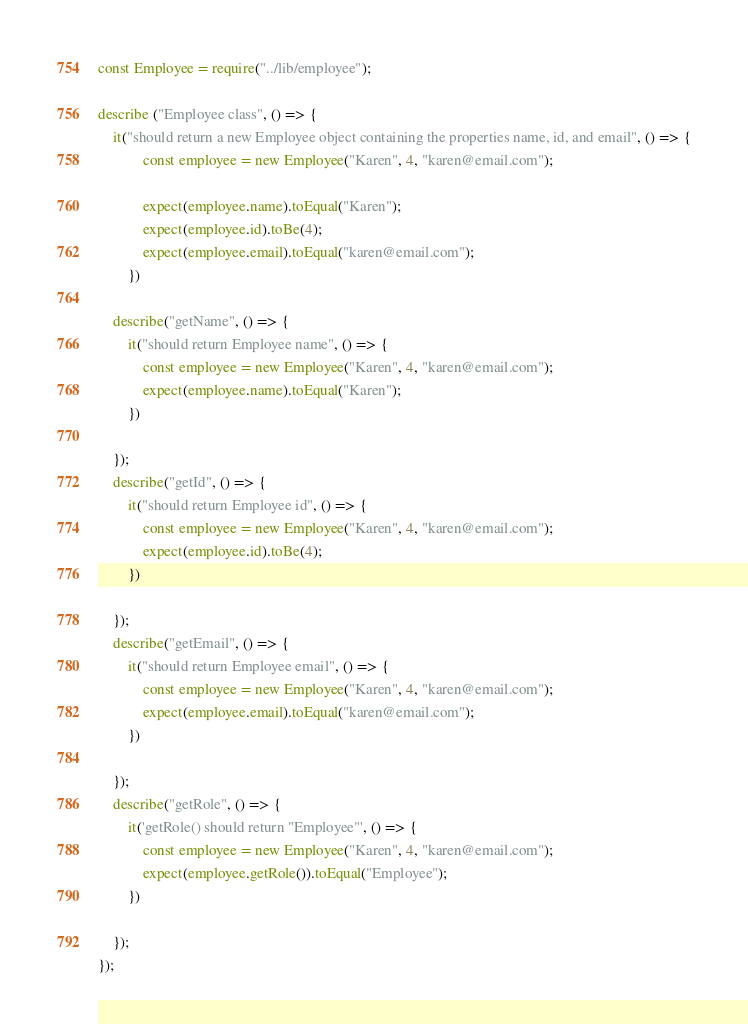<code> <loc_0><loc_0><loc_500><loc_500><_JavaScript_>const Employee = require("../lib/employee");

describe ("Employee class", () => {
    it("should return a new Employee object containing the properties name, id, and email", () => {
            const employee = new Employee("Karen", 4, "karen@email.com");

            expect(employee.name).toEqual("Karen");
            expect(employee.id).toBe(4);
            expect(employee.email).toEqual("karen@email.com");
        })
    
    describe("getName", () => {
        it("should return Employee name", () => {
            const employee = new Employee("Karen", 4, "karen@email.com");
            expect(employee.name).toEqual("Karen");
        })
        
    });
    describe("getId", () => {
        it("should return Employee id", () => {
            const employee = new Employee("Karen", 4, "karen@email.com");
            expect(employee.id).toBe(4);
        })

    });
    describe("getEmail", () => {
        it("should return Employee email", () => {
            const employee = new Employee("Karen", 4, "karen@email.com");
            expect(employee.email).toEqual("karen@email.com");
        })

    });
    describe("getRole", () => {
        it('getRole() should return "Employee"', () => {
            const employee = new Employee("Karen", 4, "karen@email.com");
            expect(employee.getRole()).toEqual("Employee");
        })

    });
});</code> 